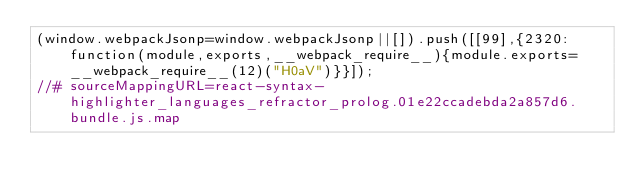Convert code to text. <code><loc_0><loc_0><loc_500><loc_500><_JavaScript_>(window.webpackJsonp=window.webpackJsonp||[]).push([[99],{2320:function(module,exports,__webpack_require__){module.exports=__webpack_require__(12)("H0aV")}}]);
//# sourceMappingURL=react-syntax-highlighter_languages_refractor_prolog.01e22ccadebda2a857d6.bundle.js.map</code> 